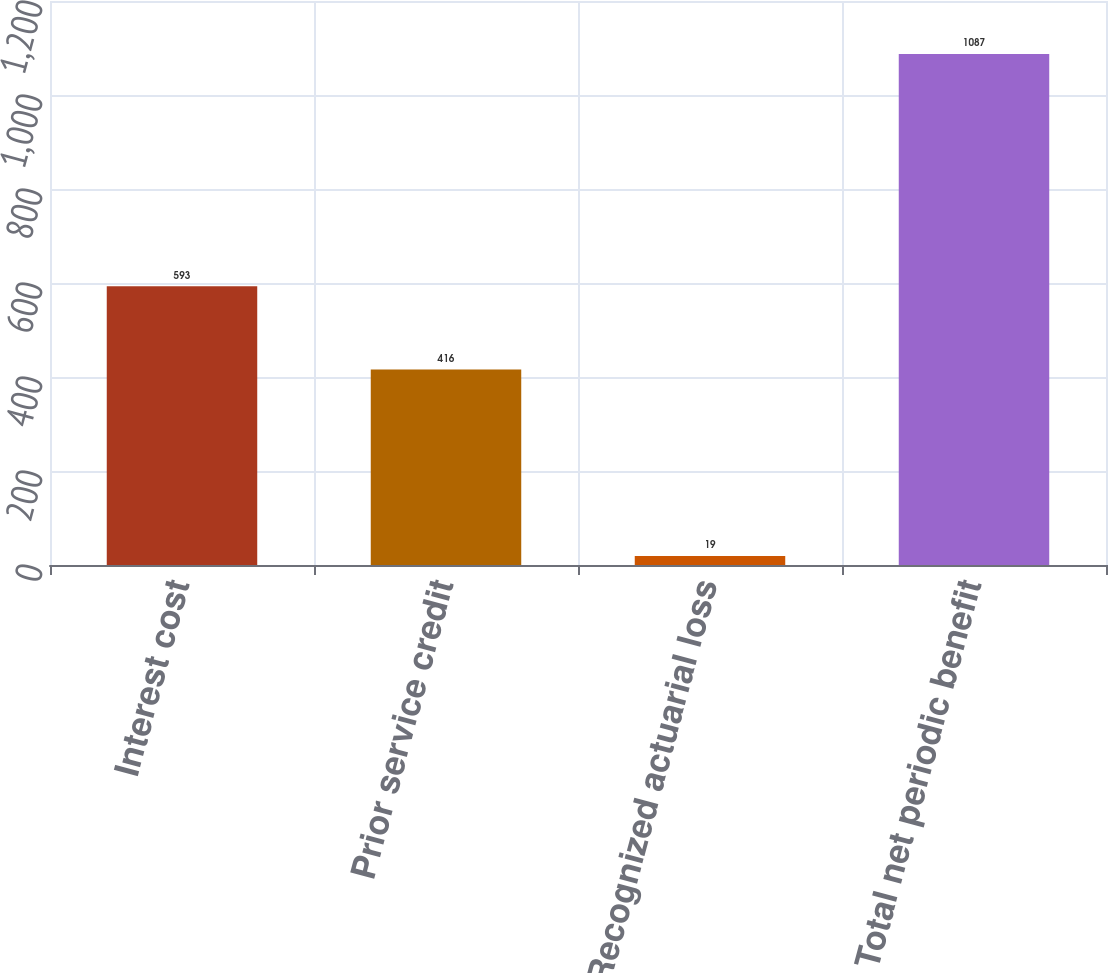Convert chart to OTSL. <chart><loc_0><loc_0><loc_500><loc_500><bar_chart><fcel>Interest cost<fcel>Prior service credit<fcel>Recognized actuarial loss<fcel>Total net periodic benefit<nl><fcel>593<fcel>416<fcel>19<fcel>1087<nl></chart> 